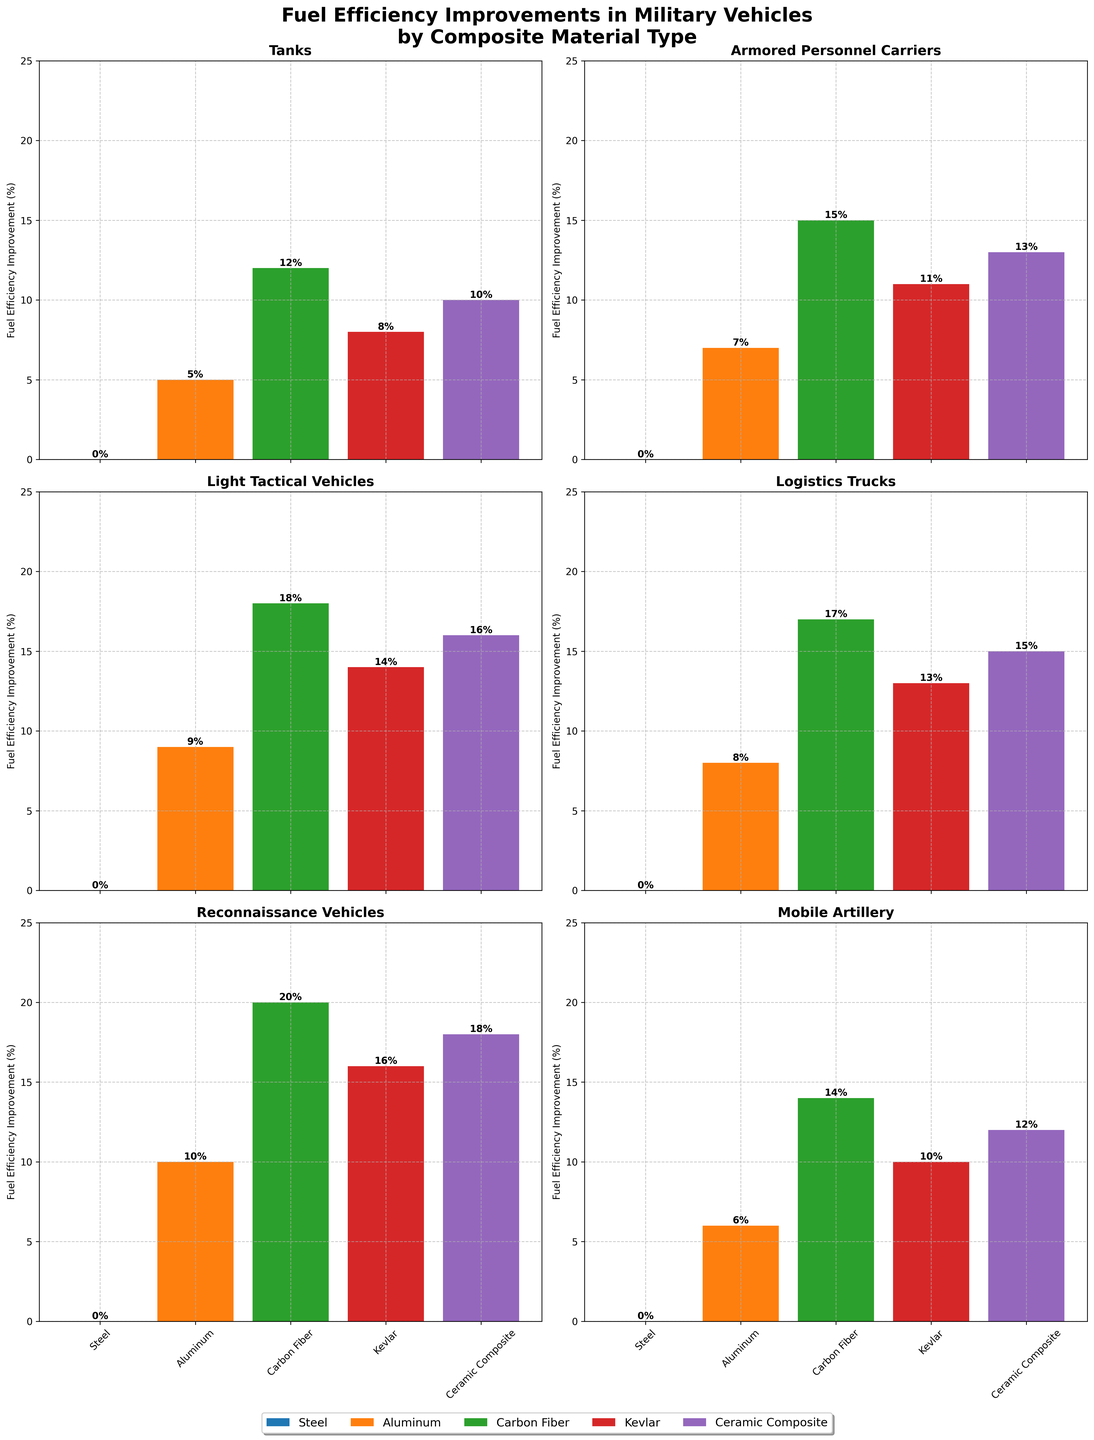What is the fuel efficiency improvement for Light Tactical Vehicles using Carbon Fiber compared to Kevlar? The figure shows that Carbon Fiber provides an 18% fuel efficiency improvement for Light Tactical Vehicles, while Kevlar provides a 14% improvement. Thus, the difference can be calculated as 18% - 14% = 4%.
Answer: 4% Which vehicle type has the highest fuel efficiency improvement using Aluminum? Observing the heights of the bars for Aluminum across all subplots, Reconnaissance Vehicles have the highest bar with an improvement of 10%.
Answer: Reconnaissance Vehicles What is the average fuel efficiency improvement for Mine-Resistant Ambush Protected vehicles using Kevlar and Ceramic Composite? The figure shows that Kevlar improves efficiency by 9% and Ceramic Composite by 11% for Mine-Resistant Ambush Protected vehicles. The average of these two is (9% + 11%) / 2 = 10%.
Answer: 10% Compare the fuel efficiency improvement for Tanks using Kevlar and Armored Personnel Carriers using Ceramic Composite. Which one is higher? From the figure, the efficiency improvement for Tanks using Kevlar is 8%, while for Armored Personnel Carriers using Ceramic Composite, it is 13%. Therefore, the improvement for Armored Personnel Carriers using Ceramic Composite is higher.
Answer: Armored Personnel Carriers using Ceramic Composite What is the total fuel efficiency improvement for Unmanned Ground Vehicles using all composite materials except Steel? The improvements for Unmanned Ground Vehicles are 11% (Aluminum), 22% (Carbon Fiber), 18% (Kevlar), and 20% (Ceramic Composite). Summing these gives 11% + 22% + 18% + 20% = 71%.
Answer: 71% Identify the vehicle type with the smallest fuel efficiency improvement using Kevlar and state the value. By checking the heights of Kevlar bars, Mobile Artillery has the smallest improvement at 10%.
Answer: Mobile Artillery, 10% Compare the fuel efficiency improvements for Logistics Trucks and Reconnaissance Vehicles using Carbon Fiber. What is the difference? Logistics Trucks have a 17% improvement using Carbon Fiber, and Reconnaissance Vehicles have a 20% improvement. The difference is calculated as 20% - 17% = 3%.
Answer: 3% How does the improvement in Amphibious Assault Vehicles using Ceramic Composite compare to that in Mobile Artillery using the same material? For Amphibious Assault Vehicles, the improvement is 14%, while for Mobile Artillery, it is 12%. Thus, the improvement for Amphibious Assault Vehicles is higher.
Answer: Amphibious Assault Vehicles Which material shows the highest average fuel efficiency improvement across all vehicle types plotted? Calculate the average improvement for each material: Aluminum (7 + 9 + 8 + 10 + 6 + 7) / 6 = 7.83%, Carbon Fiber (12 + 15 + 18 + 17 + 20 + 14 + 16 + 13 + 22 + 13) / 10 = 16%, Kevlar (8 + 11 + 14 + 13 + 16 + 10 + 12 + 9 + 18 + 9) / 10 = 12%, Ceramic Composite (10 + 13 + 16 + 15 + 18 + 12 + 14 + 11 + 20 + 11) / 10 = 14%. Carbon Fiber has the highest average improvement.
Answer: Carbon Fiber 